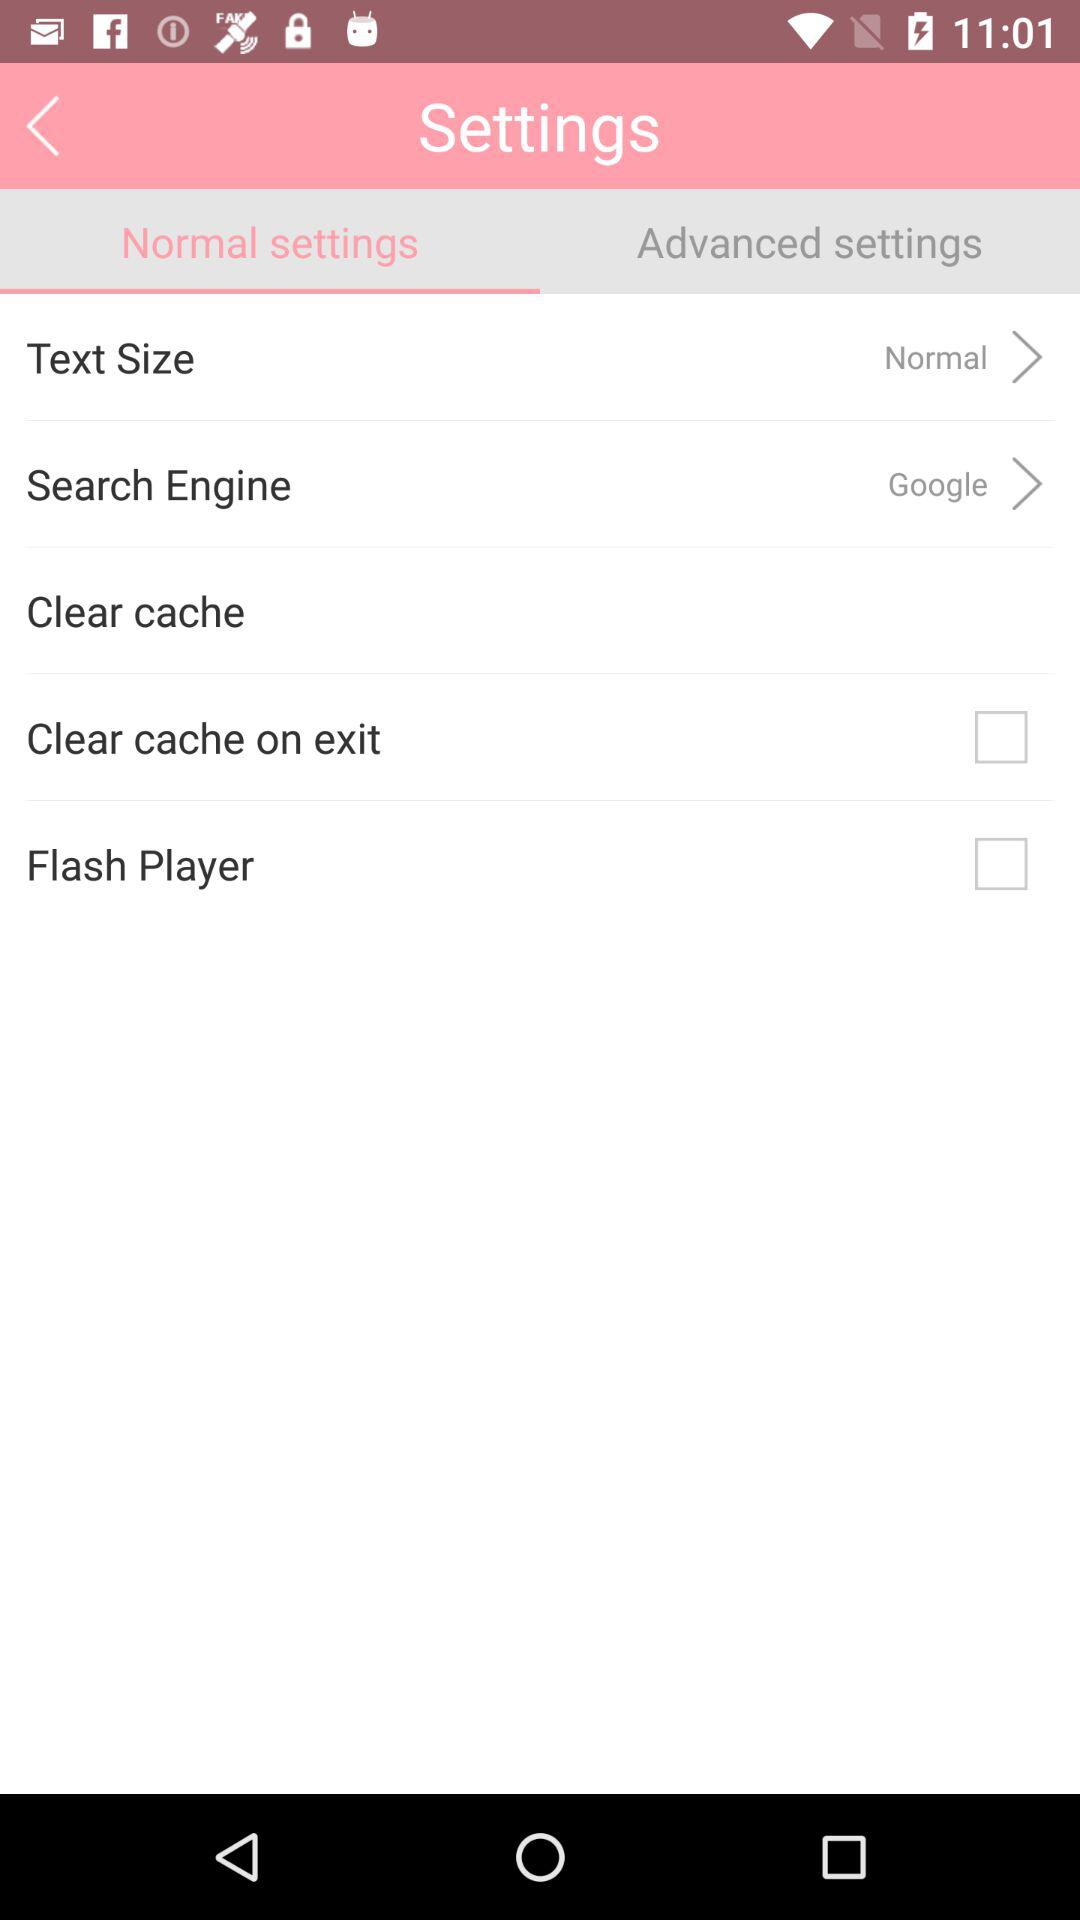Is "Clear cache on exit" checked or unchecked? "Clear cache on exit" is unchecked. 